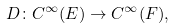<formula> <loc_0><loc_0><loc_500><loc_500>D \colon C ^ { \infty } ( E ) \to C ^ { \infty } ( F ) ,</formula> 